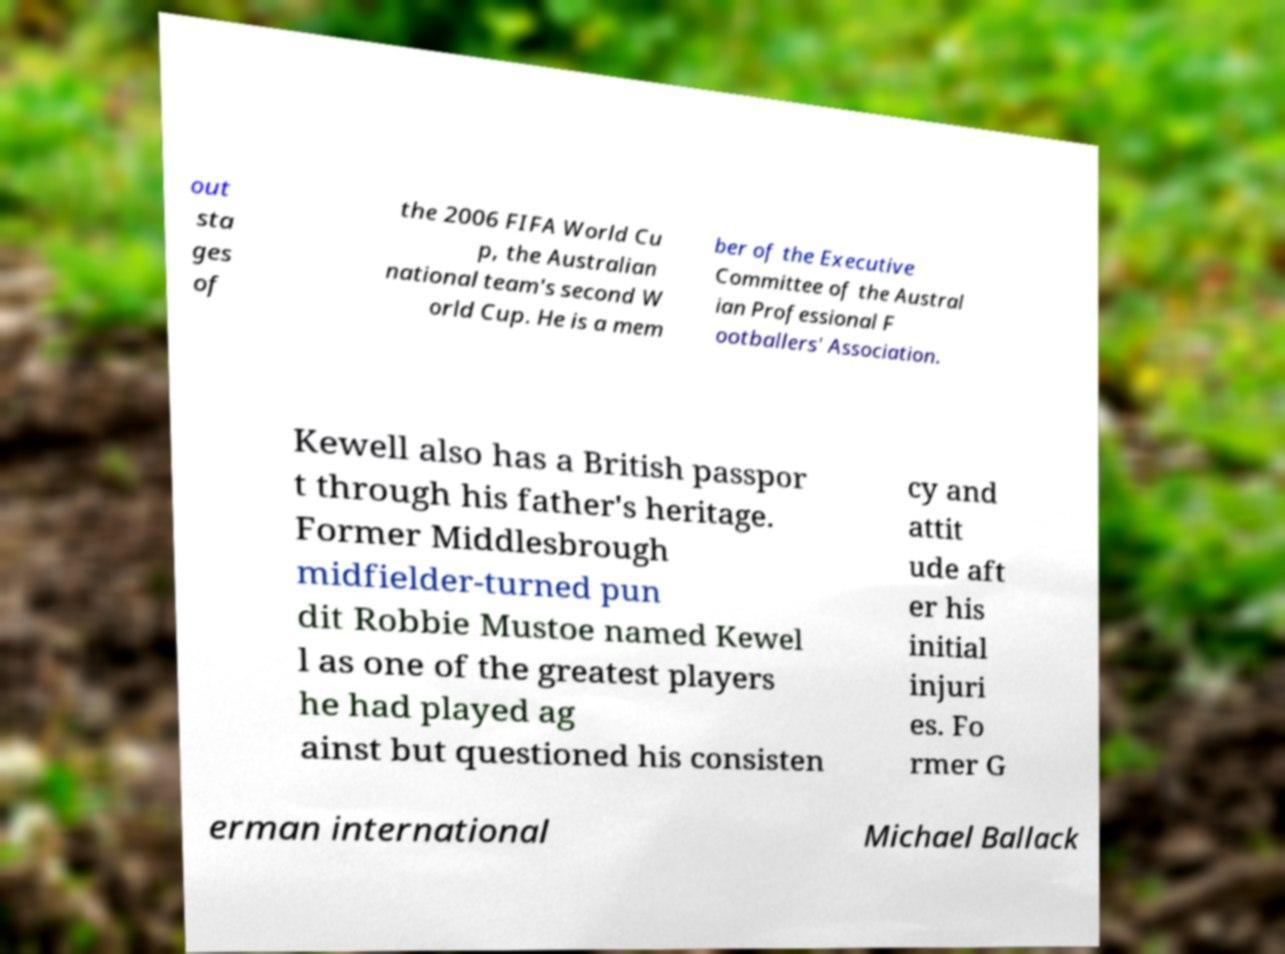What messages or text are displayed in this image? I need them in a readable, typed format. out sta ges of the 2006 FIFA World Cu p, the Australian national team's second W orld Cup. He is a mem ber of the Executive Committee of the Austral ian Professional F ootballers' Association. Kewell also has a British passpor t through his father's heritage. Former Middlesbrough midfielder-turned pun dit Robbie Mustoe named Kewel l as one of the greatest players he had played ag ainst but questioned his consisten cy and attit ude aft er his initial injuri es. Fo rmer G erman international Michael Ballack 